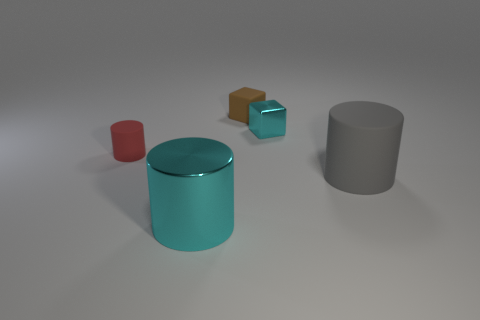There is a cylinder that is the same color as the small metallic cube; what is its material?
Offer a very short reply. Metal. There is a thing on the left side of the large cyan cylinder; is it the same size as the matte cylinder that is to the right of the large cyan metal cylinder?
Your answer should be very brief. No. There is a large thing on the right side of the large metal object; what shape is it?
Give a very brief answer. Cylinder. There is a big cyan object that is the same shape as the tiny red matte thing; what is its material?
Ensure brevity in your answer.  Metal. Is the size of the thing in front of the gray object the same as the cyan metal cube?
Your answer should be very brief. No. There is a tiny metallic thing; how many cyan objects are left of it?
Give a very brief answer. 1. Is the number of cyan shiny cylinders that are right of the tiny brown matte object less than the number of big rubber objects that are to the left of the shiny cylinder?
Your answer should be very brief. No. How many green shiny spheres are there?
Your answer should be very brief. 0. The metal cylinder that is to the left of the brown block is what color?
Your answer should be very brief. Cyan. The red cylinder has what size?
Offer a terse response. Small. 